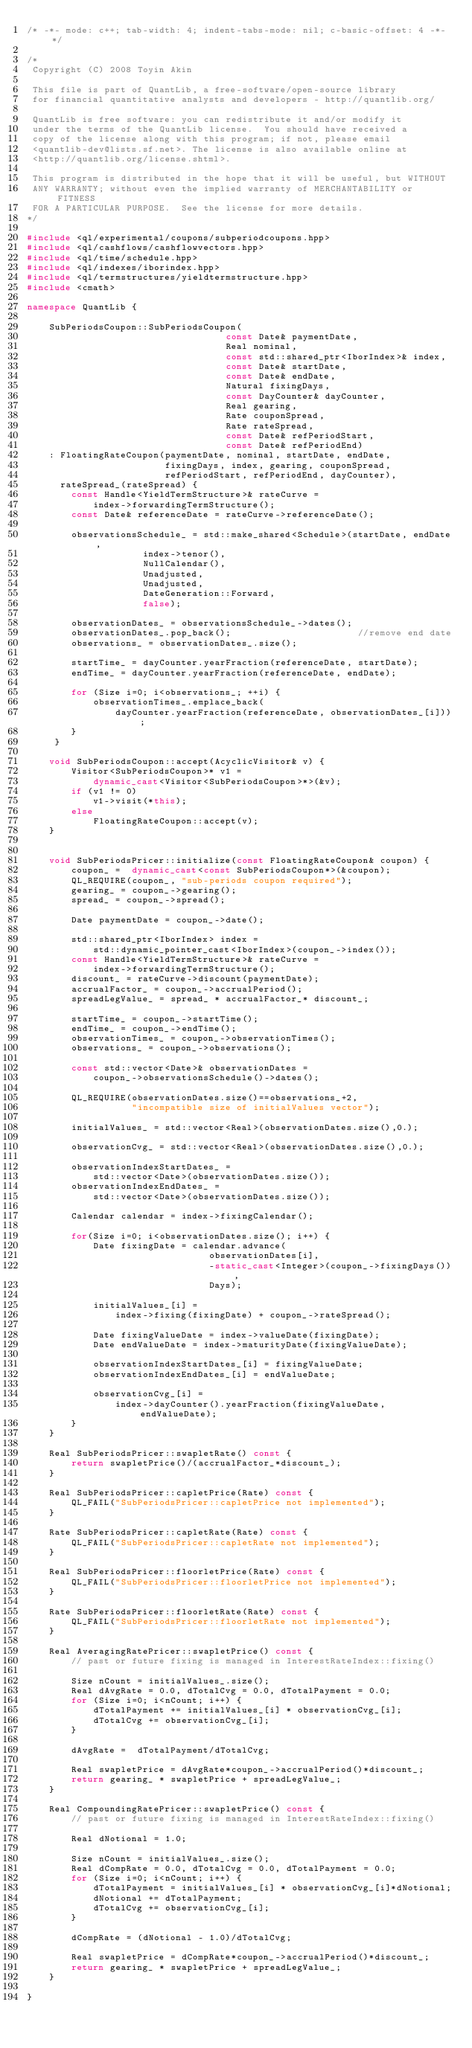Convert code to text. <code><loc_0><loc_0><loc_500><loc_500><_C++_>/* -*- mode: c++; tab-width: 4; indent-tabs-mode: nil; c-basic-offset: 4 -*- */

/*
 Copyright (C) 2008 Toyin Akin

 This file is part of QuantLib, a free-software/open-source library
 for financial quantitative analysts and developers - http://quantlib.org/

 QuantLib is free software: you can redistribute it and/or modify it
 under the terms of the QuantLib license.  You should have received a
 copy of the license along with this program; if not, please email
 <quantlib-dev@lists.sf.net>. The license is also available online at
 <http://quantlib.org/license.shtml>.

 This program is distributed in the hope that it will be useful, but WITHOUT
 ANY WARRANTY; without even the implied warranty of MERCHANTABILITY or FITNESS
 FOR A PARTICULAR PURPOSE.  See the license for more details.
*/

#include <ql/experimental/coupons/subperiodcoupons.hpp>
#include <ql/cashflows/cashflowvectors.hpp>
#include <ql/time/schedule.hpp>
#include <ql/indexes/iborindex.hpp>
#include <ql/termstructures/yieldtermstructure.hpp>
#include <cmath>

namespace QuantLib {

    SubPeriodsCoupon::SubPeriodsCoupon(
                                    const Date& paymentDate,
                                    Real nominal,
                                    const std::shared_ptr<IborIndex>& index,
                                    const Date& startDate,
                                    const Date& endDate,
                                    Natural fixingDays,
                                    const DayCounter& dayCounter,
                                    Real gearing,
                                    Rate couponSpread,
                                    Rate rateSpread,
                                    const Date& refPeriodStart,
                                    const Date& refPeriodEnd)
    : FloatingRateCoupon(paymentDate, nominal, startDate, endDate,
                         fixingDays, index, gearing, couponSpread,
                         refPeriodStart, refPeriodEnd, dayCounter),
      rateSpread_(rateSpread) {
        const Handle<YieldTermStructure>& rateCurve =
            index->forwardingTermStructure();
        const Date& referenceDate = rateCurve->referenceDate();

        observationsSchedule_ = std::make_shared<Schedule>(startDate, endDate,
                     index->tenor(),
                     NullCalendar(),
                     Unadjusted,
                     Unadjusted,
                     DateGeneration::Forward,
                     false);

        observationDates_ = observationsSchedule_->dates();
        observationDates_.pop_back();                       //remove end date
        observations_ = observationDates_.size();

        startTime_ = dayCounter.yearFraction(referenceDate, startDate);
        endTime_ = dayCounter.yearFraction(referenceDate, endDate);

        for (Size i=0; i<observations_; ++i) {
            observationTimes_.emplace_back(
                dayCounter.yearFraction(referenceDate, observationDates_[i]));
        }
     }

    void SubPeriodsCoupon::accept(AcyclicVisitor& v) {
        Visitor<SubPeriodsCoupon>* v1 =
            dynamic_cast<Visitor<SubPeriodsCoupon>*>(&v);
        if (v1 != 0)
            v1->visit(*this);
        else
            FloatingRateCoupon::accept(v);
    }


    void SubPeriodsPricer::initialize(const FloatingRateCoupon& coupon) {
        coupon_ =  dynamic_cast<const SubPeriodsCoupon*>(&coupon);
        QL_REQUIRE(coupon_, "sub-periods coupon required");
        gearing_ = coupon_->gearing();
        spread_ = coupon_->spread();

        Date paymentDate = coupon_->date();

        std::shared_ptr<IborIndex> index =
            std::dynamic_pointer_cast<IborIndex>(coupon_->index());
        const Handle<YieldTermStructure>& rateCurve =
            index->forwardingTermStructure();
        discount_ = rateCurve->discount(paymentDate);
        accrualFactor_ = coupon_->accrualPeriod();
        spreadLegValue_ = spread_ * accrualFactor_* discount_;

        startTime_ = coupon_->startTime();
        endTime_ = coupon_->endTime();
        observationTimes_ = coupon_->observationTimes();
        observations_ = coupon_->observations();

        const std::vector<Date>& observationDates =
            coupon_->observationsSchedule()->dates();

        QL_REQUIRE(observationDates.size()==observations_+2,
                   "incompatible size of initialValues vector");

        initialValues_ = std::vector<Real>(observationDates.size(),0.);

        observationCvg_ = std::vector<Real>(observationDates.size(),0.);

        observationIndexStartDates_ =
            std::vector<Date>(observationDates.size());
        observationIndexEndDates_ =
            std::vector<Date>(observationDates.size());

        Calendar calendar = index->fixingCalendar();

        for(Size i=0; i<observationDates.size(); i++) {
            Date fixingDate = calendar.advance(
                                 observationDates[i],
                                 -static_cast<Integer>(coupon_->fixingDays()),
                                 Days);

            initialValues_[i] =
                index->fixing(fixingDate) + coupon_->rateSpread();

            Date fixingValueDate = index->valueDate(fixingDate);
            Date endValueDate = index->maturityDate(fixingValueDate);

            observationIndexStartDates_[i] = fixingValueDate;
            observationIndexEndDates_[i] = endValueDate;

            observationCvg_[i] =
                index->dayCounter().yearFraction(fixingValueDate, endValueDate);
        }
    }

    Real SubPeriodsPricer::swapletRate() const {
        return swapletPrice()/(accrualFactor_*discount_);
    }

    Real SubPeriodsPricer::capletPrice(Rate) const {
        QL_FAIL("SubPeriodsPricer::capletPrice not implemented");
    }

    Rate SubPeriodsPricer::capletRate(Rate) const {
        QL_FAIL("SubPeriodsPricer::capletRate not implemented");
    }

    Real SubPeriodsPricer::floorletPrice(Rate) const {
        QL_FAIL("SubPeriodsPricer::floorletPrice not implemented");
    }

    Rate SubPeriodsPricer::floorletRate(Rate) const {
        QL_FAIL("SubPeriodsPricer::floorletRate not implemented");
    }

    Real AveragingRatePricer::swapletPrice() const {
        // past or future fixing is managed in InterestRateIndex::fixing()

        Size nCount = initialValues_.size();
        Real dAvgRate = 0.0, dTotalCvg = 0.0, dTotalPayment = 0.0;
        for (Size i=0; i<nCount; i++) {
            dTotalPayment += initialValues_[i] * observationCvg_[i];
            dTotalCvg += observationCvg_[i];
        }

        dAvgRate =  dTotalPayment/dTotalCvg;

        Real swapletPrice = dAvgRate*coupon_->accrualPeriod()*discount_;
        return gearing_ * swapletPrice + spreadLegValue_;
    }

    Real CompoundingRatePricer::swapletPrice() const {
        // past or future fixing is managed in InterestRateIndex::fixing()

        Real dNotional = 1.0;

        Size nCount = initialValues_.size();
        Real dCompRate = 0.0, dTotalCvg = 0.0, dTotalPayment = 0.0;
        for (Size i=0; i<nCount; i++) {
            dTotalPayment = initialValues_[i] * observationCvg_[i]*dNotional;
            dNotional += dTotalPayment;
            dTotalCvg += observationCvg_[i];
        }

        dCompRate = (dNotional - 1.0)/dTotalCvg;

        Real swapletPrice = dCompRate*coupon_->accrualPeriod()*discount_;
        return gearing_ * swapletPrice + spreadLegValue_;
    }

}

</code> 